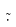Convert formula to latex. <formula><loc_0><loc_0><loc_500><loc_500>\tilde { \cdot }</formula> 